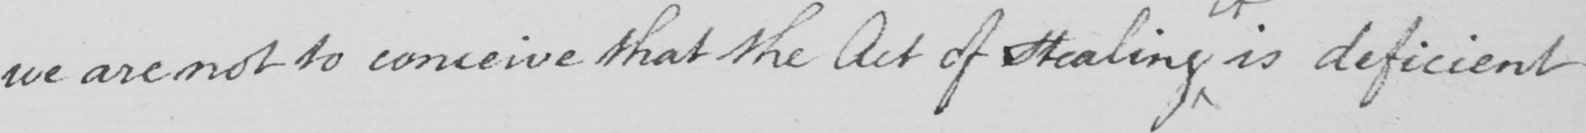Can you tell me what this handwritten text says? we are not to conceive that the Act of Stealing is deficient 